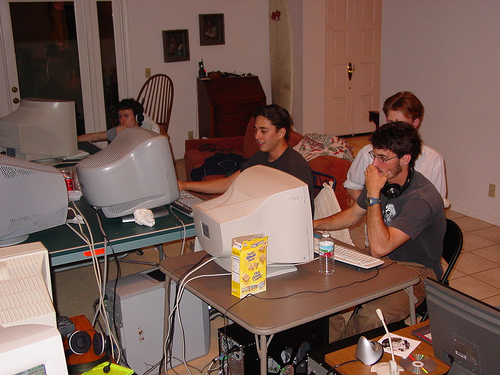Are the people in the image well-defined? The individuals in the image are quite discernible, with their faces and upper bodies visible and distinguishable from one another. They are engaged in various activities in what appears to be a room set up with multiple computer monitors, reflecting a casual and perhaps collaborative environment. 